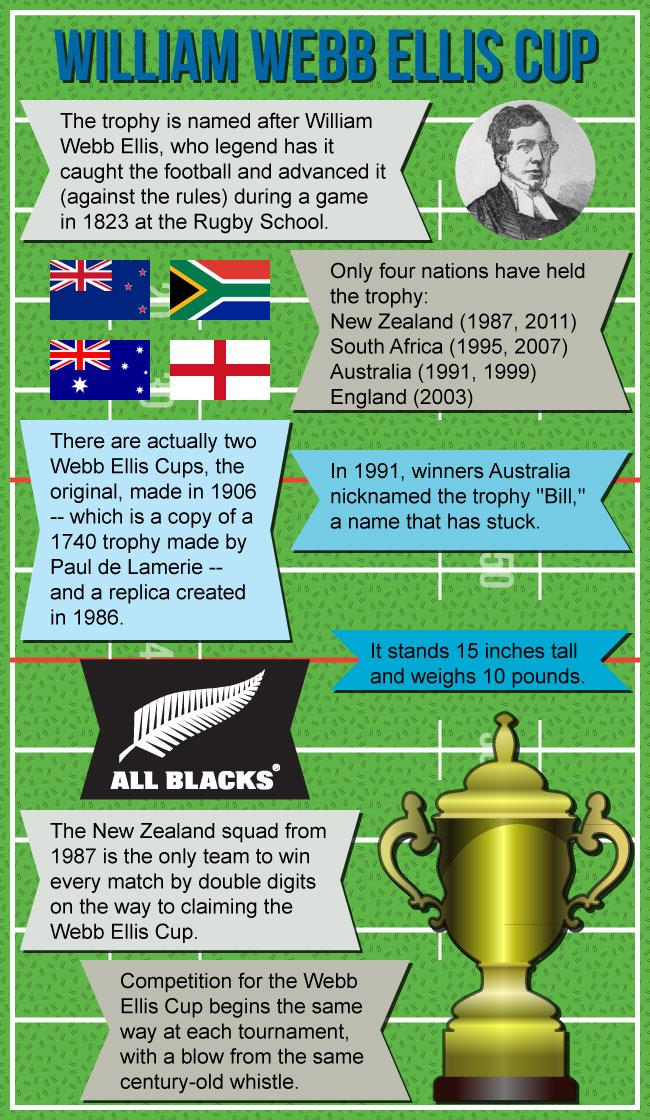Draw attention to some important aspects in this diagram. England is the only country to have won the Webb Ellis Cup once. With a two-digit victory in every match, the squad known as the All Blacks has proven to be a dominant force in the sport. The replicas of the Web Ellis cup were made in 1906 and 1986. 